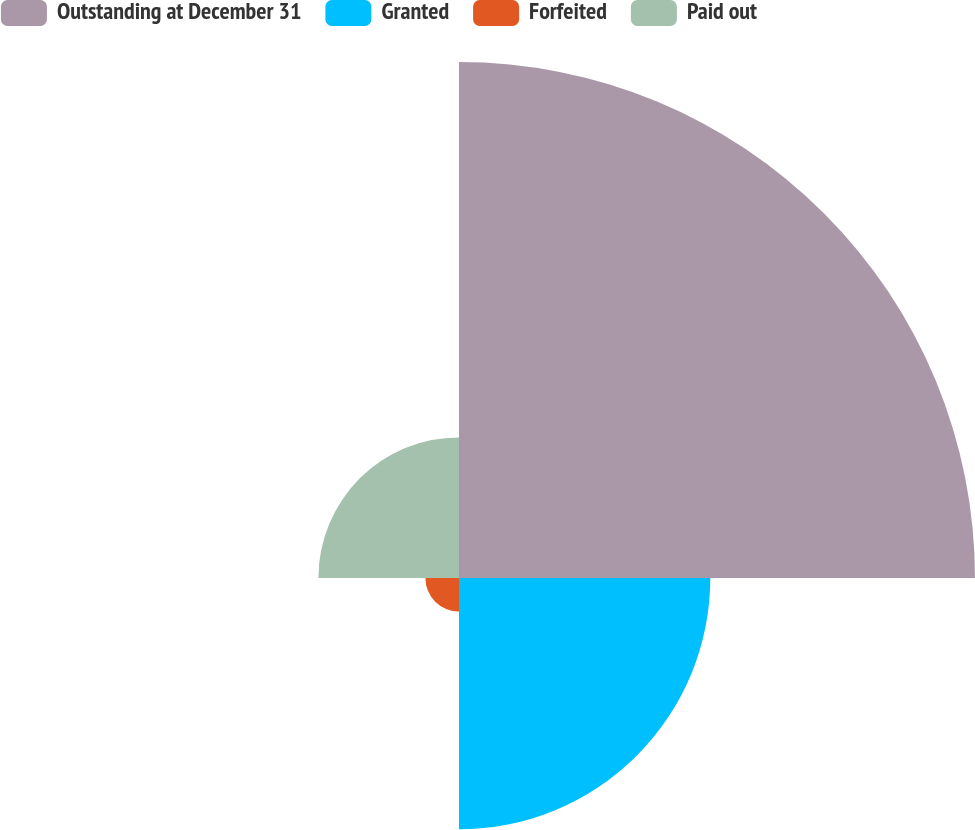Convert chart. <chart><loc_0><loc_0><loc_500><loc_500><pie_chart><fcel>Outstanding at December 31<fcel>Granted<fcel>Forfeited<fcel>Paid out<nl><fcel>54.8%<fcel>26.69%<fcel>3.57%<fcel>14.93%<nl></chart> 